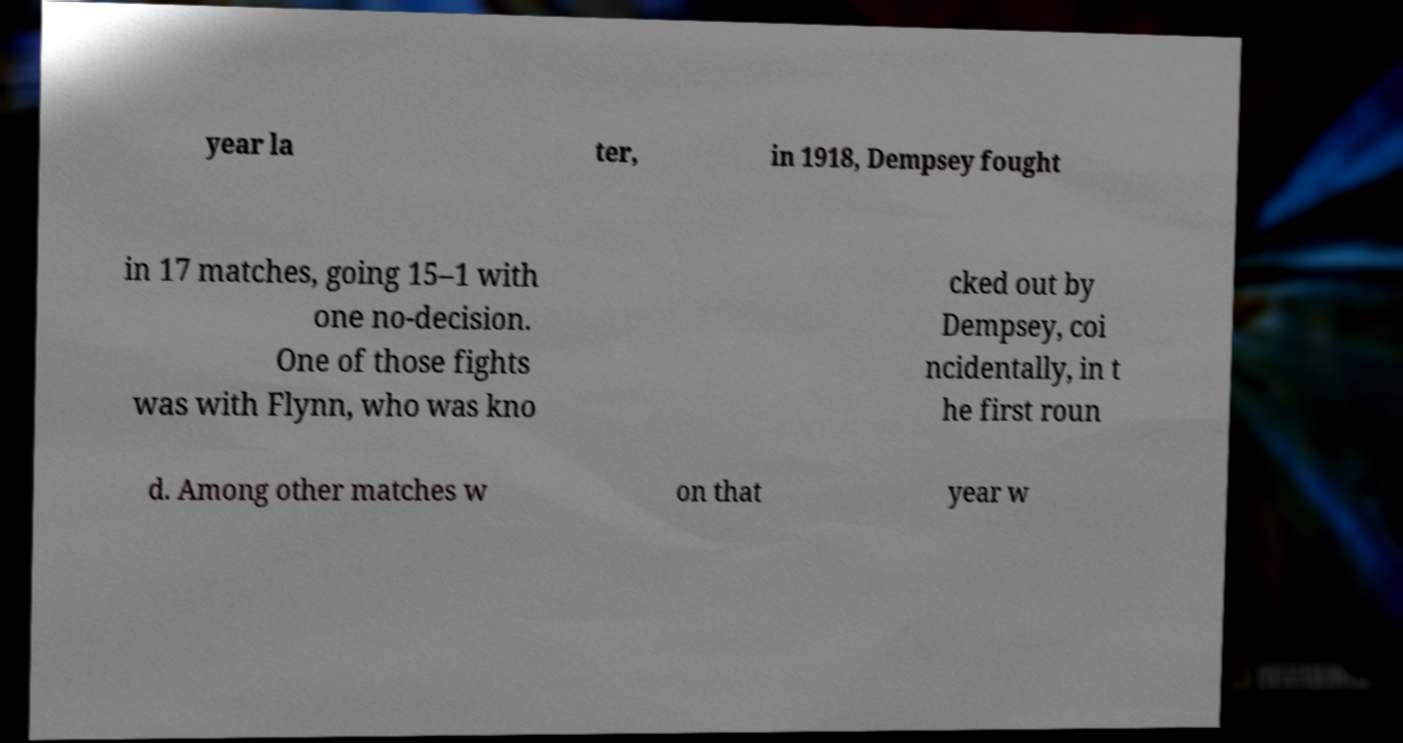I need the written content from this picture converted into text. Can you do that? year la ter, in 1918, Dempsey fought in 17 matches, going 15–1 with one no-decision. One of those fights was with Flynn, who was kno cked out by Dempsey, coi ncidentally, in t he first roun d. Among other matches w on that year w 